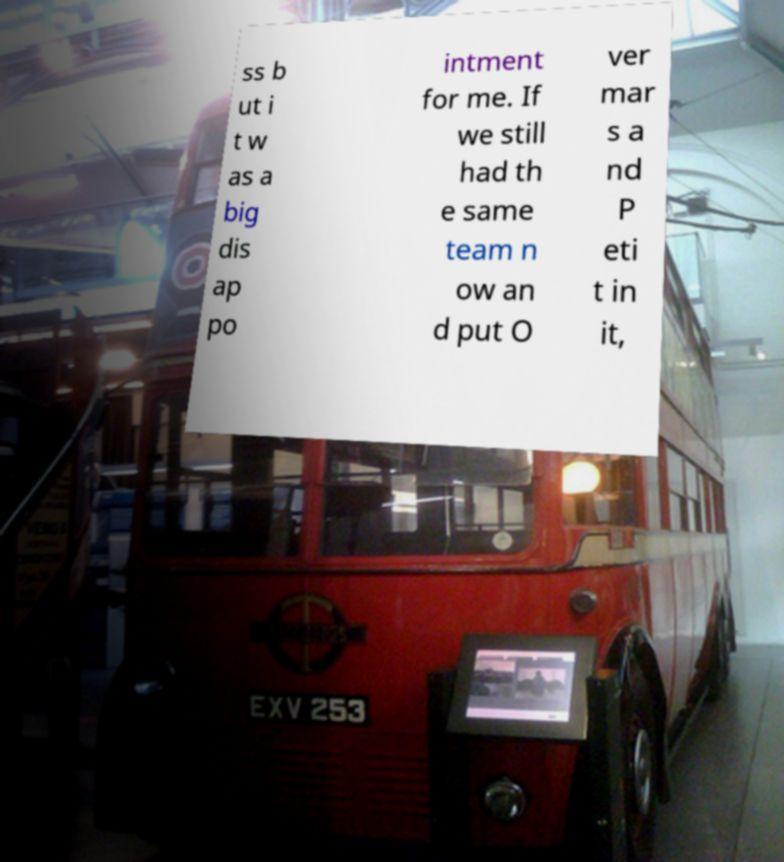Please read and relay the text visible in this image. What does it say? ss b ut i t w as a big dis ap po intment for me. If we still had th e same team n ow an d put O ver mar s a nd P eti t in it, 